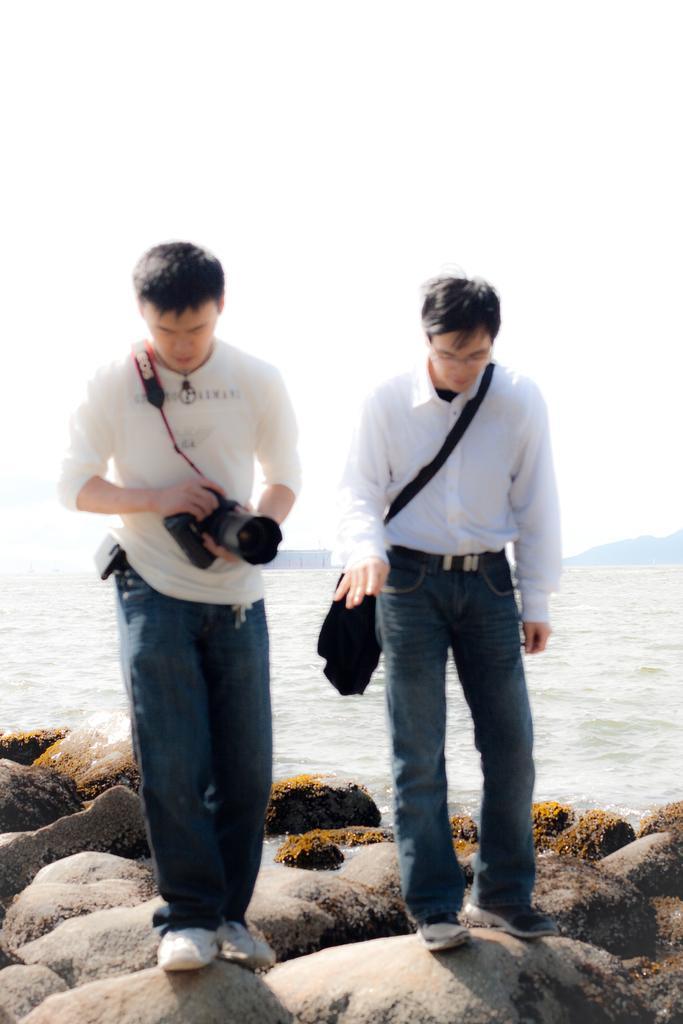How would you summarize this image in a sentence or two? In this image we can see two persons standing on the rocks, among them one person is holding a camera and the other person is carrying a bag, there are some rocks, water and mountains, in the background we can see the sky. 